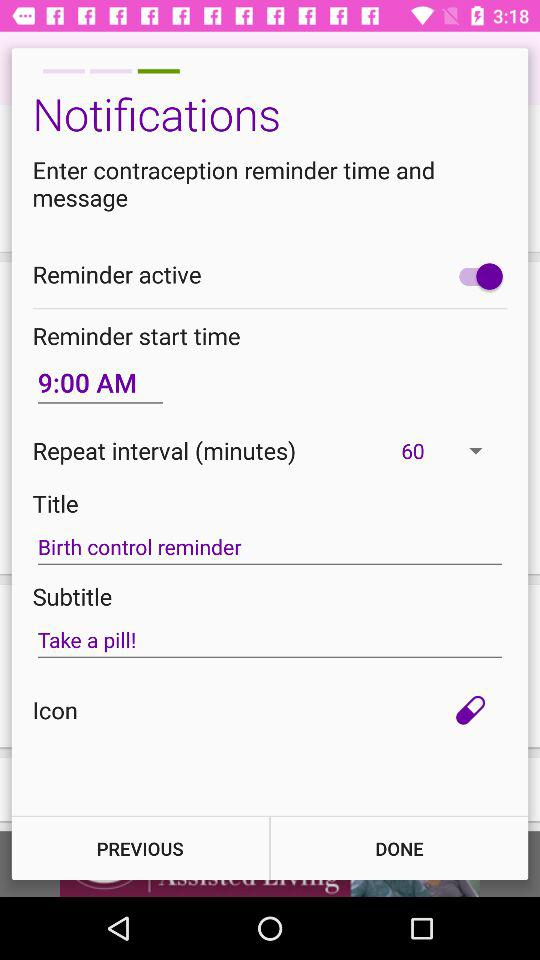What is the status of the "Reminder active"? The status is "on". 